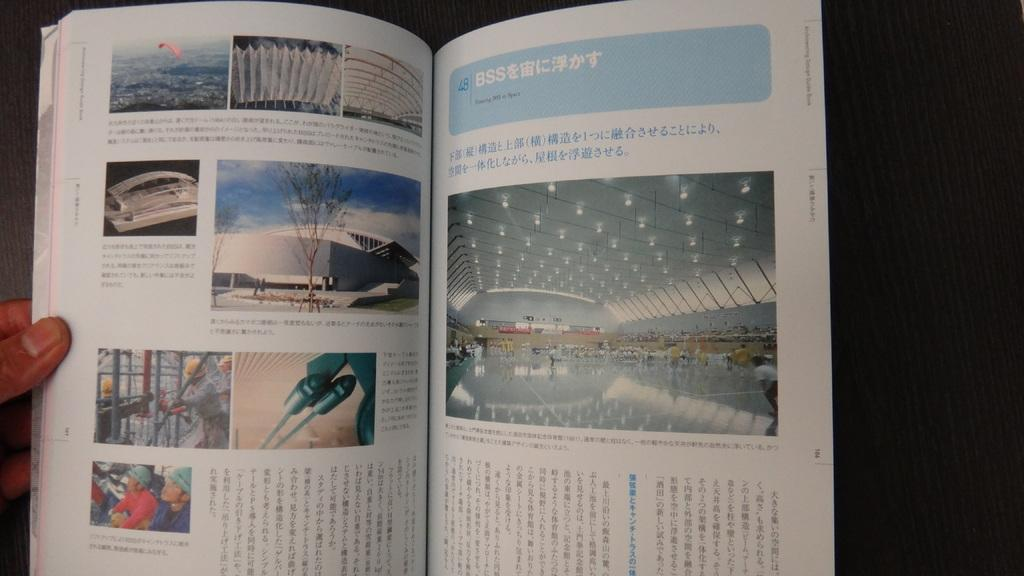<image>
Give a short and clear explanation of the subsequent image. A person is reading a book with Chinese letters and says floating BSS in space. 